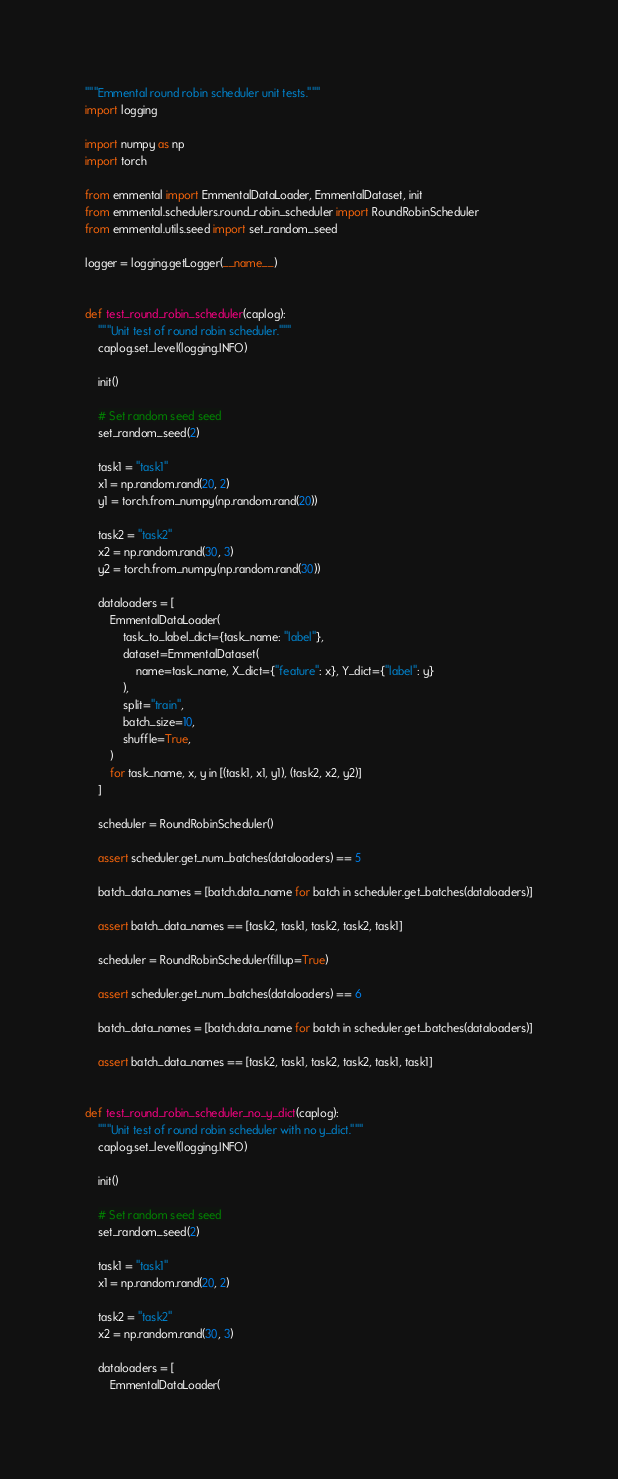<code> <loc_0><loc_0><loc_500><loc_500><_Python_>"""Emmental round robin scheduler unit tests."""
import logging

import numpy as np
import torch

from emmental import EmmentalDataLoader, EmmentalDataset, init
from emmental.schedulers.round_robin_scheduler import RoundRobinScheduler
from emmental.utils.seed import set_random_seed

logger = logging.getLogger(__name__)


def test_round_robin_scheduler(caplog):
    """Unit test of round robin scheduler."""
    caplog.set_level(logging.INFO)

    init()

    # Set random seed seed
    set_random_seed(2)

    task1 = "task1"
    x1 = np.random.rand(20, 2)
    y1 = torch.from_numpy(np.random.rand(20))

    task2 = "task2"
    x2 = np.random.rand(30, 3)
    y2 = torch.from_numpy(np.random.rand(30))

    dataloaders = [
        EmmentalDataLoader(
            task_to_label_dict={task_name: "label"},
            dataset=EmmentalDataset(
                name=task_name, X_dict={"feature": x}, Y_dict={"label": y}
            ),
            split="train",
            batch_size=10,
            shuffle=True,
        )
        for task_name, x, y in [(task1, x1, y1), (task2, x2, y2)]
    ]

    scheduler = RoundRobinScheduler()

    assert scheduler.get_num_batches(dataloaders) == 5

    batch_data_names = [batch.data_name for batch in scheduler.get_batches(dataloaders)]

    assert batch_data_names == [task2, task1, task2, task2, task1]

    scheduler = RoundRobinScheduler(fillup=True)

    assert scheduler.get_num_batches(dataloaders) == 6

    batch_data_names = [batch.data_name for batch in scheduler.get_batches(dataloaders)]

    assert batch_data_names == [task2, task1, task2, task2, task1, task1]


def test_round_robin_scheduler_no_y_dict(caplog):
    """Unit test of round robin scheduler with no y_dict."""
    caplog.set_level(logging.INFO)

    init()

    # Set random seed seed
    set_random_seed(2)

    task1 = "task1"
    x1 = np.random.rand(20, 2)

    task2 = "task2"
    x2 = np.random.rand(30, 3)

    dataloaders = [
        EmmentalDataLoader(</code> 